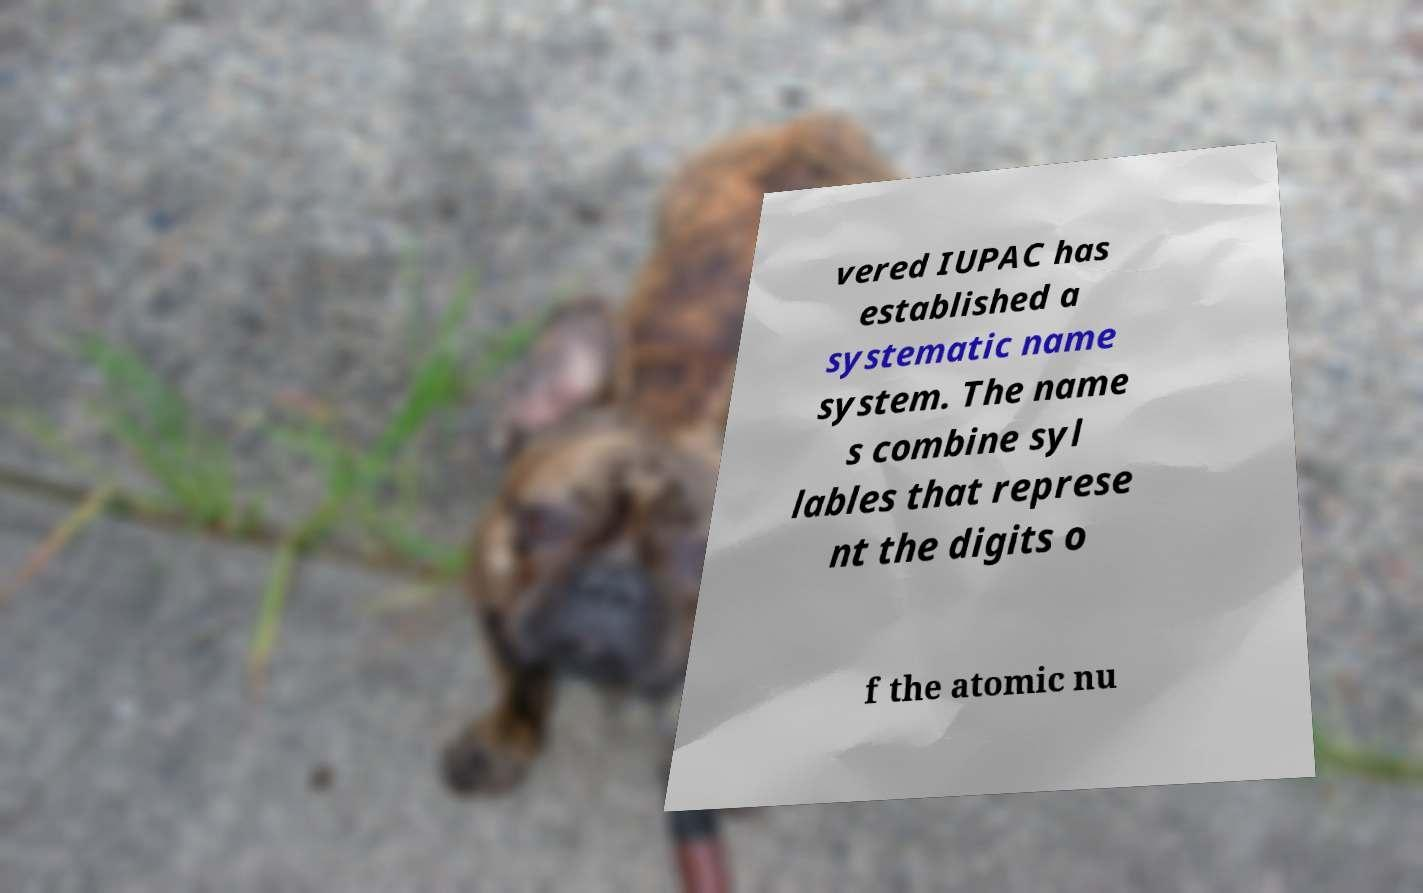Could you extract and type out the text from this image? vered IUPAC has established a systematic name system. The name s combine syl lables that represe nt the digits o f the atomic nu 